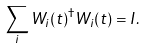Convert formula to latex. <formula><loc_0><loc_0><loc_500><loc_500>\sum _ { i } W _ { i } ( t ) ^ { \dagger } W _ { i } ( t ) = I .</formula> 